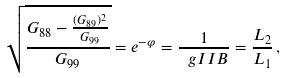Convert formula to latex. <formula><loc_0><loc_0><loc_500><loc_500>\sqrt { \frac { G _ { 8 8 } - \frac { ( G _ { 8 9 } ) ^ { 2 } } { G _ { 9 9 } } } { G _ { 9 9 } } } = e ^ { - \varphi } = \frac { 1 } { \ g I I B } = \frac { L _ { 2 } } { L _ { 1 } } \, ,</formula> 